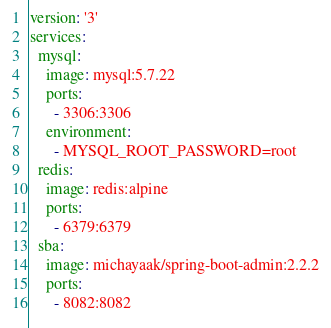<code> <loc_0><loc_0><loc_500><loc_500><_YAML_>version: '3'
services:
  mysql:
    image: mysql:5.7.22
    ports:
      - 3306:3306
    environment:
      - MYSQL_ROOT_PASSWORD=root
  redis:
    image: redis:alpine
    ports:
      - 6379:6379
  sba:
    image: michayaak/spring-boot-admin:2.2.2
    ports:
      - 8082:8082</code> 